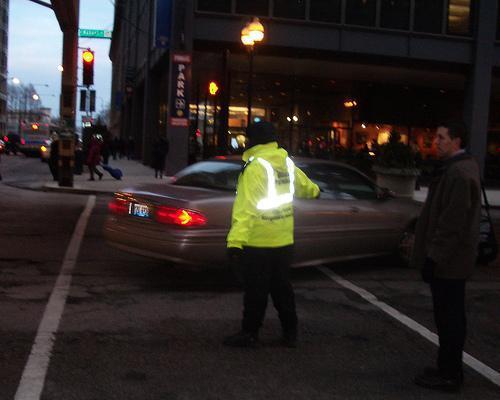How many cars are turning right?
Give a very brief answer. 1. How many buses are there?
Give a very brief answer. 1. How many cops are directing traffic?
Give a very brief answer. 1. 